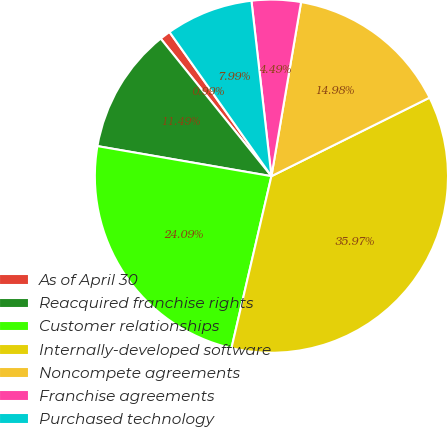Convert chart to OTSL. <chart><loc_0><loc_0><loc_500><loc_500><pie_chart><fcel>As of April 30<fcel>Reacquired franchise rights<fcel>Customer relationships<fcel>Internally-developed software<fcel>Noncompete agreements<fcel>Franchise agreements<fcel>Purchased technology<nl><fcel>0.99%<fcel>11.49%<fcel>24.09%<fcel>35.97%<fcel>14.98%<fcel>4.49%<fcel>7.99%<nl></chart> 